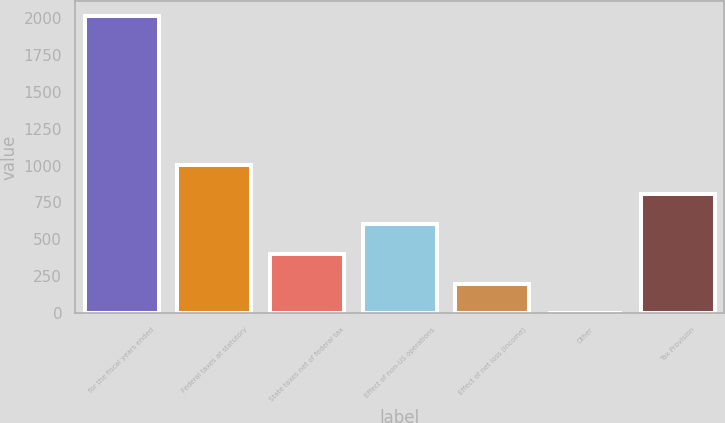Convert chart. <chart><loc_0><loc_0><loc_500><loc_500><bar_chart><fcel>for the fiscal years ended<fcel>Federal taxes at statutory<fcel>State taxes net of federal tax<fcel>Effect of non-US operations<fcel>Effect of net loss (income)<fcel>Other<fcel>Tax Provision<nl><fcel>2011<fcel>1005.64<fcel>402.43<fcel>603.5<fcel>201.36<fcel>0.29<fcel>804.57<nl></chart> 